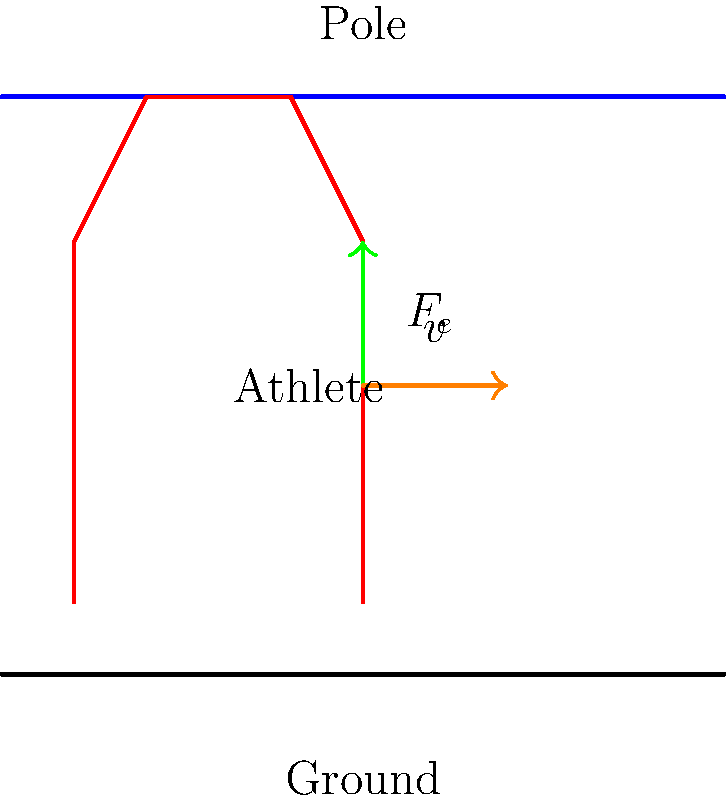A pole vaulter of mass 70 kg bends their pole, storing 2000 J of elastic potential energy. As the pole straightens, it transfers all of this energy to the vaulter. Assuming no energy losses, what is the vaulter's speed just as they leave the pole, before gravity starts to slow them down? To solve this problem, we'll use the principle of conservation of energy and the equation for kinetic energy. Here's a step-by-step approach:

1) Initially, the energy is stored as elastic potential energy in the bent pole:
   $E_{\text{elastic}} = 2000 \text{ J}$

2) This energy is completely transferred to the vaulter as kinetic energy:
   $E_{\text{kinetic}} = 2000 \text{ J}$

3) The equation for kinetic energy is:
   $E_{\text{kinetic}} = \frac{1}{2}mv^2$

4) We know the mass $m = 70 \text{ kg}$, so we can substitute these values:
   $2000 = \frac{1}{2} \cdot 70 \cdot v^2$

5) Simplify:
   $2000 = 35v^2$

6) Divide both sides by 35:
   $\frac{2000}{35} = v^2$

7) Take the square root of both sides:
   $v = \sqrt{\frac{2000}{35}} \approx 7.56 \text{ m/s}$

Therefore, the vaulter's speed just as they leave the pole is approximately 7.56 m/s.
Answer: 7.56 m/s 